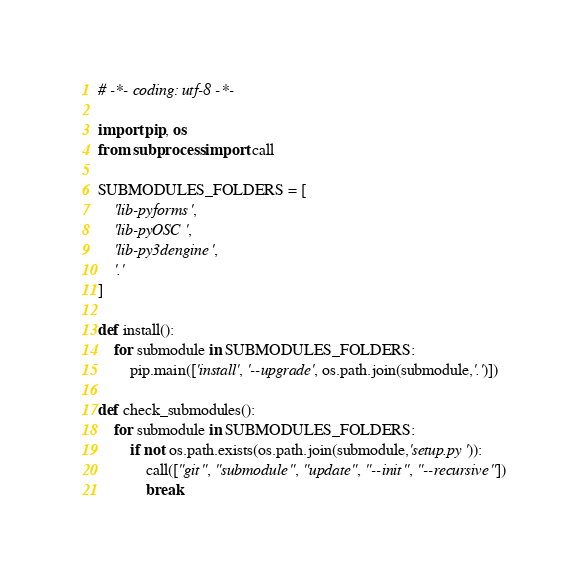<code> <loc_0><loc_0><loc_500><loc_500><_Python_># -*- coding: utf-8 -*-

import pip, os
from subprocess import call

SUBMODULES_FOLDERS = [
    'lib-pyforms',
    'lib-pyOSC',
    'lib-py3dengine',
    '.'
]

def install():
    for submodule in SUBMODULES_FOLDERS:
        pip.main(['install', '--upgrade', os.path.join(submodule,'.')])

def check_submodules():
    for submodule in SUBMODULES_FOLDERS:
        if not os.path.exists(os.path.join(submodule,'setup.py')):
            call(["git", "submodule", "update", "--init", "--recursive"])
            break
</code> 